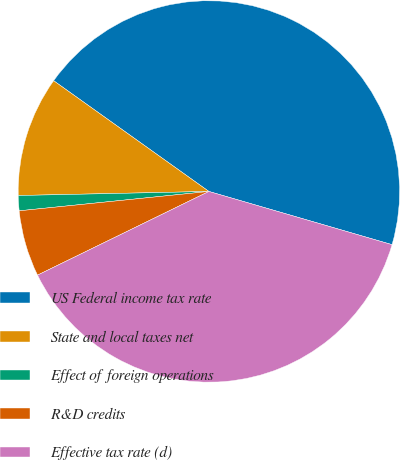Convert chart. <chart><loc_0><loc_0><loc_500><loc_500><pie_chart><fcel>US Federal income tax rate<fcel>State and local taxes net<fcel>Effect of foreign operations<fcel>R&D credits<fcel>Effective tax rate (d)<nl><fcel>44.64%<fcel>10.2%<fcel>1.28%<fcel>5.61%<fcel>38.27%<nl></chart> 